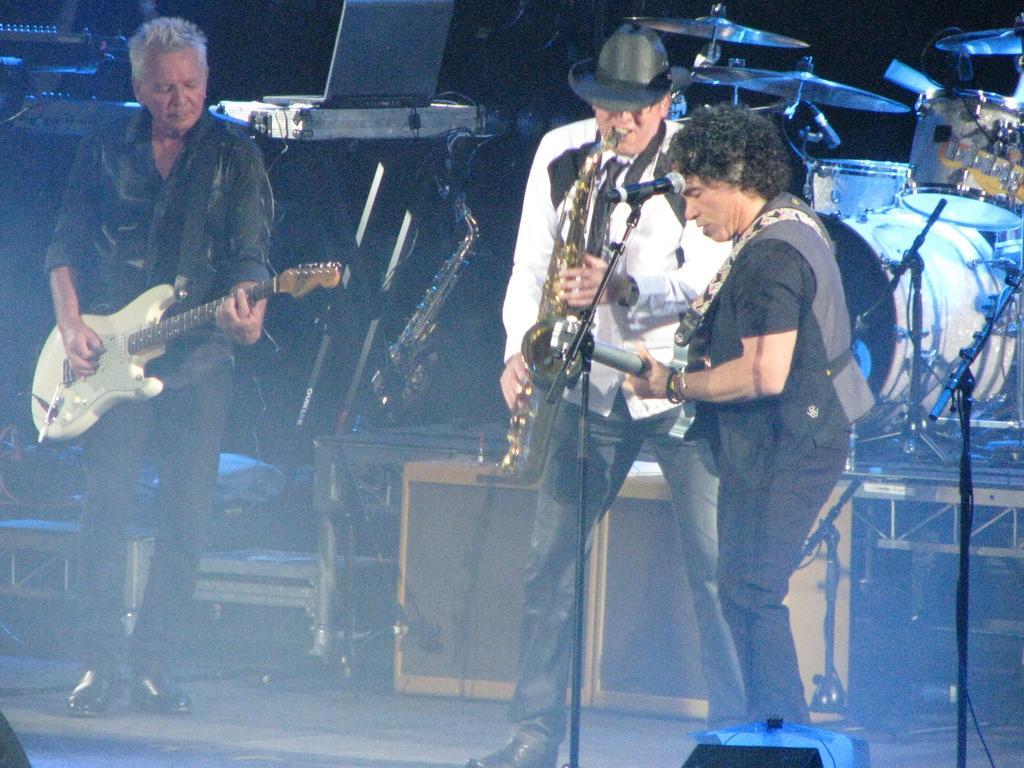Could you give a brief overview of what you see in this image? In the image there are three men playing guitar and singing on mic. In the background there are many musical instruments on the left side there is a drum kit and on the middle there is a piano ,it seems to be a concert. 